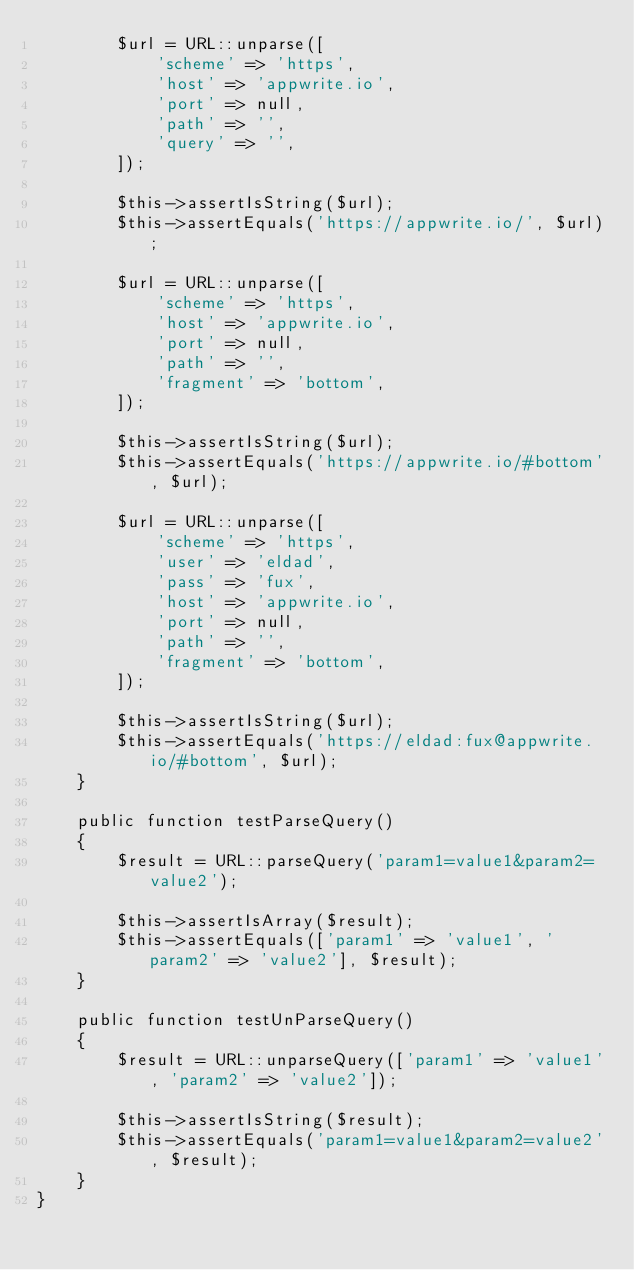Convert code to text. <code><loc_0><loc_0><loc_500><loc_500><_PHP_>        $url = URL::unparse([
            'scheme' => 'https',
            'host' => 'appwrite.io',
            'port' => null,
            'path' => '',
            'query' => '',
        ]);

        $this->assertIsString($url);
        $this->assertEquals('https://appwrite.io/', $url);

        $url = URL::unparse([
            'scheme' => 'https',
            'host' => 'appwrite.io',
            'port' => null,
            'path' => '',
            'fragment' => 'bottom',
        ]);

        $this->assertIsString($url);
        $this->assertEquals('https://appwrite.io/#bottom', $url);

        $url = URL::unparse([
            'scheme' => 'https',
            'user' => 'eldad',
            'pass' => 'fux',
            'host' => 'appwrite.io',
            'port' => null,
            'path' => '',
            'fragment' => 'bottom',
        ]);

        $this->assertIsString($url);
        $this->assertEquals('https://eldad:fux@appwrite.io/#bottom', $url);
    }

    public function testParseQuery()
    {
        $result = URL::parseQuery('param1=value1&param2=value2');

        $this->assertIsArray($result);
        $this->assertEquals(['param1' => 'value1', 'param2' => 'value2'], $result);
    }

    public function testUnParseQuery()
    {
        $result = URL::unparseQuery(['param1' => 'value1', 'param2' => 'value2']);

        $this->assertIsString($result);
        $this->assertEquals('param1=value1&param2=value2', $result);
    }
}
</code> 